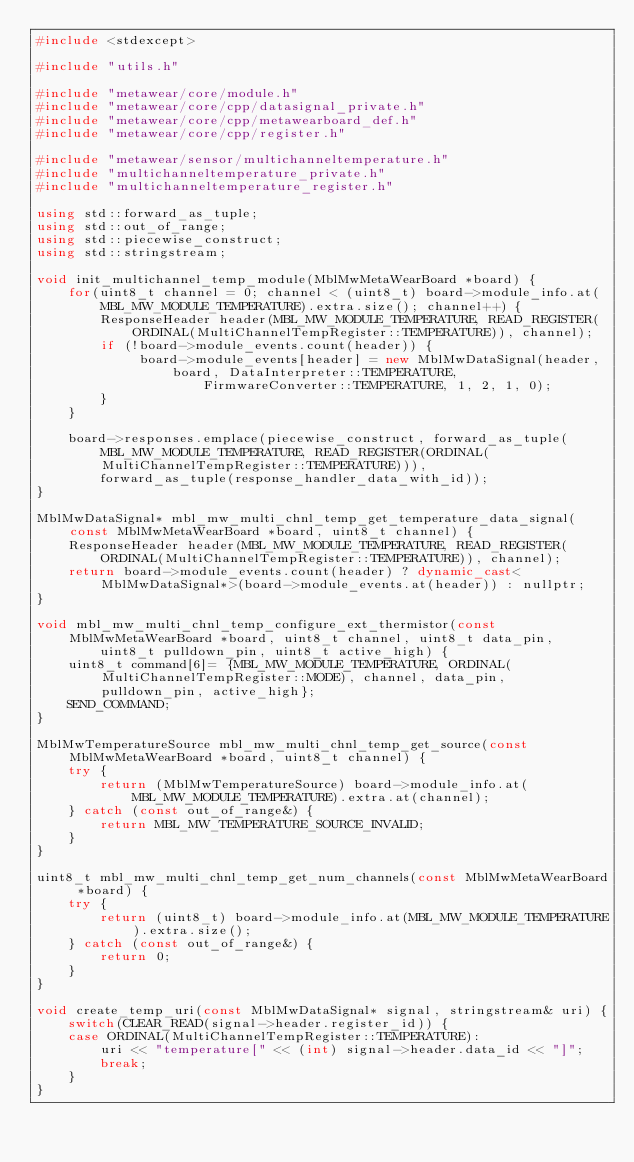Convert code to text. <code><loc_0><loc_0><loc_500><loc_500><_C++_>#include <stdexcept>

#include "utils.h"

#include "metawear/core/module.h"
#include "metawear/core/cpp/datasignal_private.h"
#include "metawear/core/cpp/metawearboard_def.h"
#include "metawear/core/cpp/register.h"

#include "metawear/sensor/multichanneltemperature.h"
#include "multichanneltemperature_private.h"
#include "multichanneltemperature_register.h"

using std::forward_as_tuple;
using std::out_of_range;
using std::piecewise_construct;
using std::stringstream;

void init_multichannel_temp_module(MblMwMetaWearBoard *board) {
    for(uint8_t channel = 0; channel < (uint8_t) board->module_info.at(MBL_MW_MODULE_TEMPERATURE).extra.size(); channel++) {
        ResponseHeader header(MBL_MW_MODULE_TEMPERATURE, READ_REGISTER(ORDINAL(MultiChannelTempRegister::TEMPERATURE)), channel);
        if (!board->module_events.count(header)) {
             board->module_events[header] = new MblMwDataSignal(header, board, DataInterpreter::TEMPERATURE, 
                     FirmwareConverter::TEMPERATURE, 1, 2, 1, 0);
        }
    }

    board->responses.emplace(piecewise_construct, forward_as_tuple(MBL_MW_MODULE_TEMPERATURE, READ_REGISTER(ORDINAL(MultiChannelTempRegister::TEMPERATURE))),
        forward_as_tuple(response_handler_data_with_id));
}

MblMwDataSignal* mbl_mw_multi_chnl_temp_get_temperature_data_signal(const MblMwMetaWearBoard *board, uint8_t channel) {
    ResponseHeader header(MBL_MW_MODULE_TEMPERATURE, READ_REGISTER(ORDINAL(MultiChannelTempRegister::TEMPERATURE)), channel);
    return board->module_events.count(header) ? dynamic_cast<MblMwDataSignal*>(board->module_events.at(header)) : nullptr;
}

void mbl_mw_multi_chnl_temp_configure_ext_thermistor(const MblMwMetaWearBoard *board, uint8_t channel, uint8_t data_pin, 
        uint8_t pulldown_pin, uint8_t active_high) {
    uint8_t command[6]= {MBL_MW_MODULE_TEMPERATURE, ORDINAL(MultiChannelTempRegister::MODE), channel, data_pin, pulldown_pin, active_high};
    SEND_COMMAND;
}

MblMwTemperatureSource mbl_mw_multi_chnl_temp_get_source(const MblMwMetaWearBoard *board, uint8_t channel) {
    try {
        return (MblMwTemperatureSource) board->module_info.at(MBL_MW_MODULE_TEMPERATURE).extra.at(channel);
    } catch (const out_of_range&) {
        return MBL_MW_TEMPERATURE_SOURCE_INVALID;
    }
}

uint8_t mbl_mw_multi_chnl_temp_get_num_channels(const MblMwMetaWearBoard *board) {
    try {
        return (uint8_t) board->module_info.at(MBL_MW_MODULE_TEMPERATURE).extra.size();
    } catch (const out_of_range&) {
        return 0;
    }
}

void create_temp_uri(const MblMwDataSignal* signal, stringstream& uri) {
    switch(CLEAR_READ(signal->header.register_id)) {
    case ORDINAL(MultiChannelTempRegister::TEMPERATURE):
        uri << "temperature[" << (int) signal->header.data_id << "]";
        break;
    }
}
</code> 